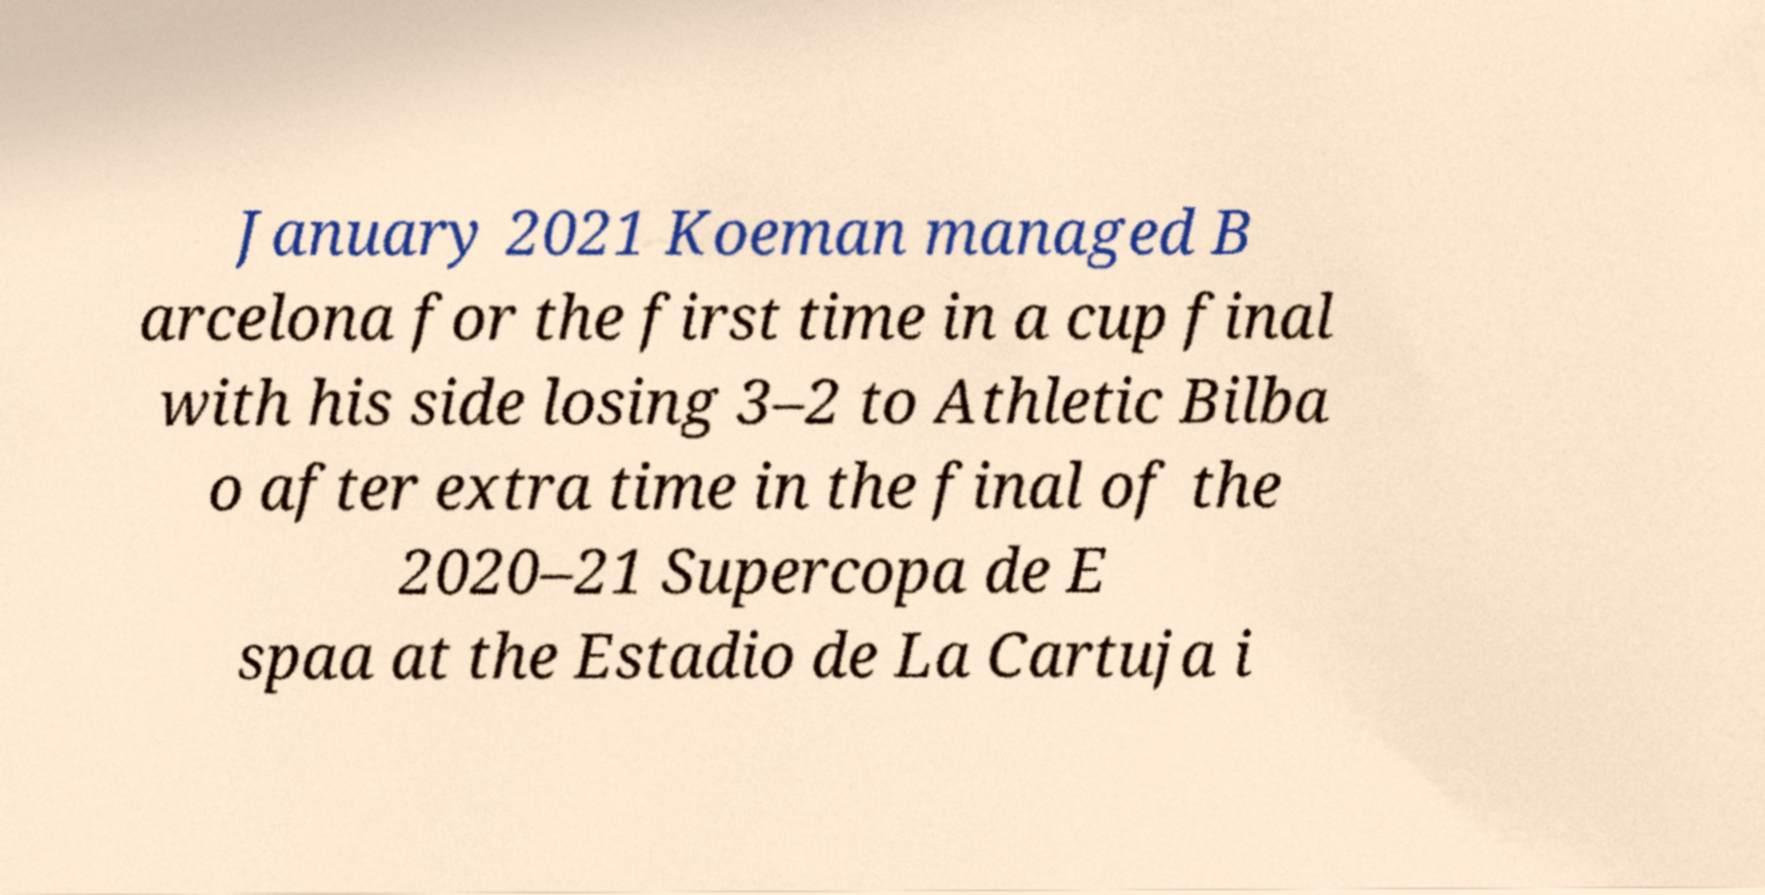What messages or text are displayed in this image? I need them in a readable, typed format. January 2021 Koeman managed B arcelona for the first time in a cup final with his side losing 3–2 to Athletic Bilba o after extra time in the final of the 2020–21 Supercopa de E spaa at the Estadio de La Cartuja i 